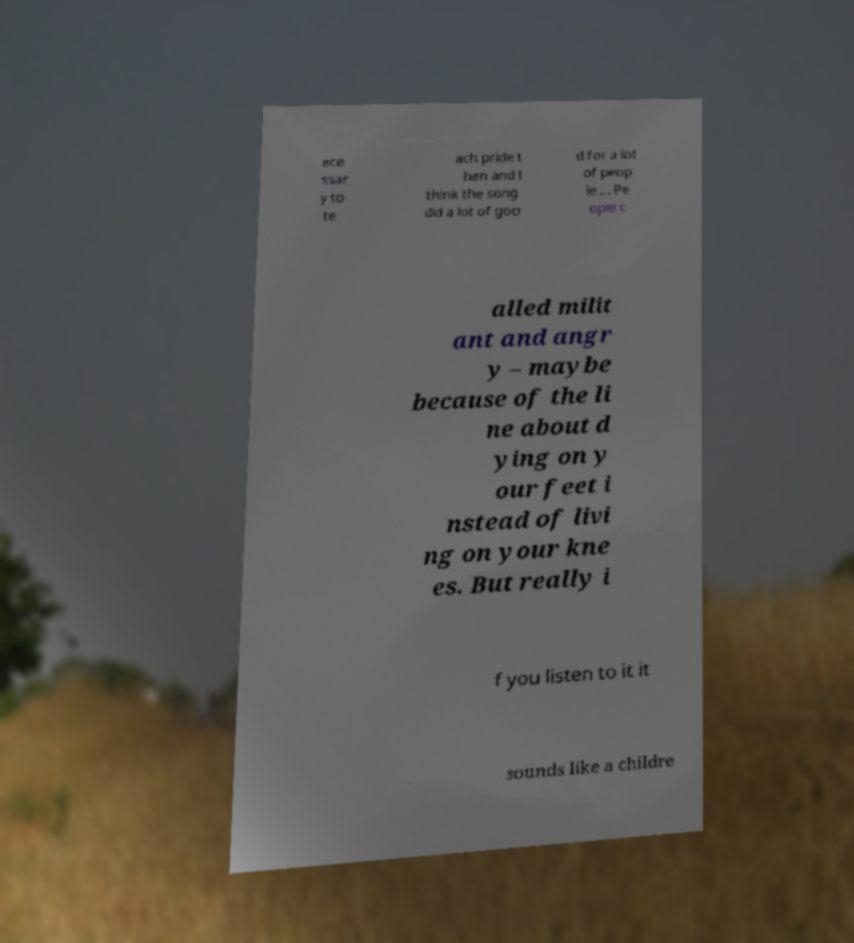Could you assist in decoding the text presented in this image and type it out clearly? ece ssar y to te ach pride t hen and I think the song did a lot of goo d for a lot of peop le ... Pe ople c alled milit ant and angr y – maybe because of the li ne about d ying on y our feet i nstead of livi ng on your kne es. But really i f you listen to it it sounds like a childre 